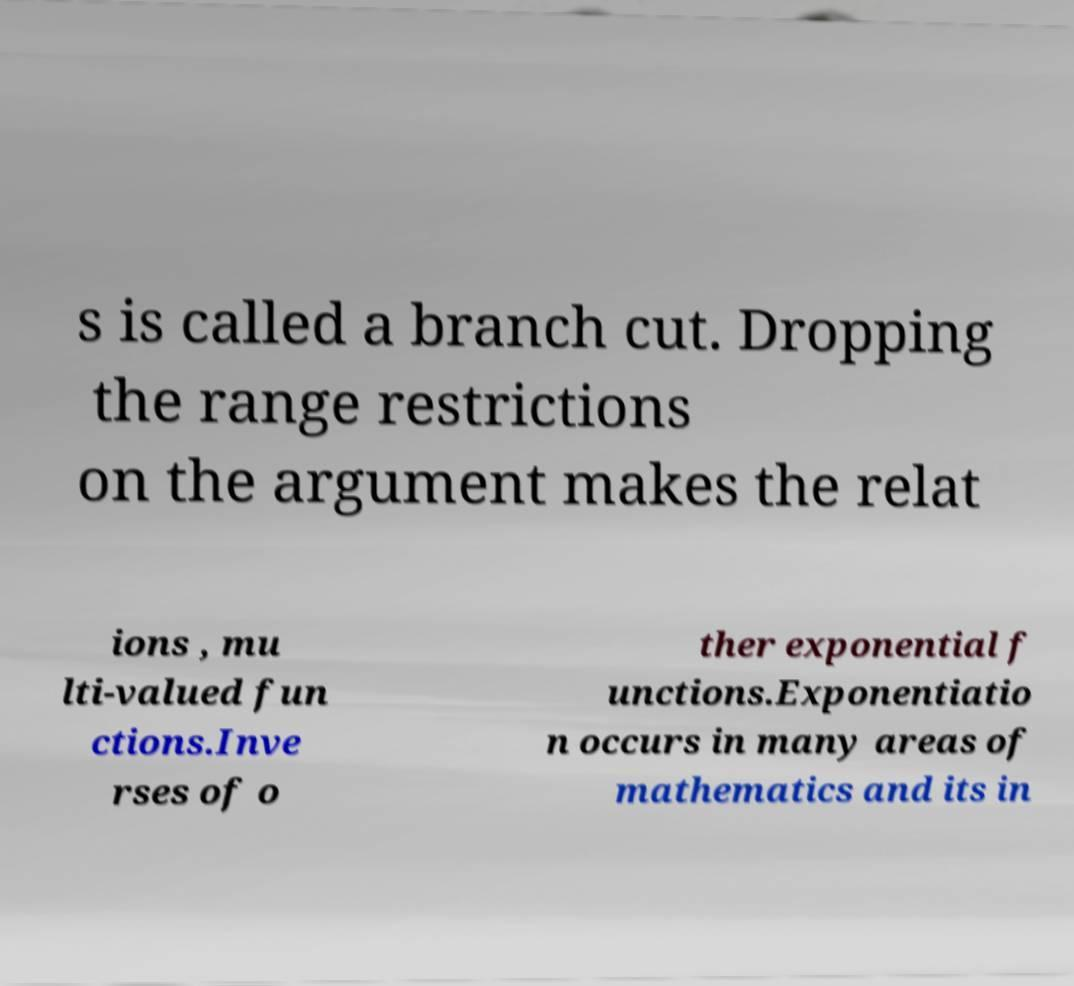I need the written content from this picture converted into text. Can you do that? s is called a branch cut. Dropping the range restrictions on the argument makes the relat ions , mu lti-valued fun ctions.Inve rses of o ther exponential f unctions.Exponentiatio n occurs in many areas of mathematics and its in 